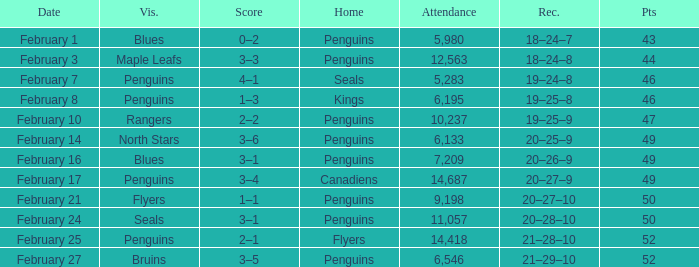Score of 2–1 has what record? 21–28–10. 